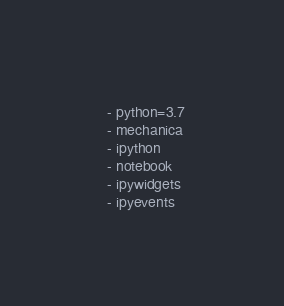Convert code to text. <code><loc_0><loc_0><loc_500><loc_500><_YAML_>  - python=3.7
  - mechanica
  - ipython
  - notebook
  - ipywidgets
  - ipyevents
</code> 